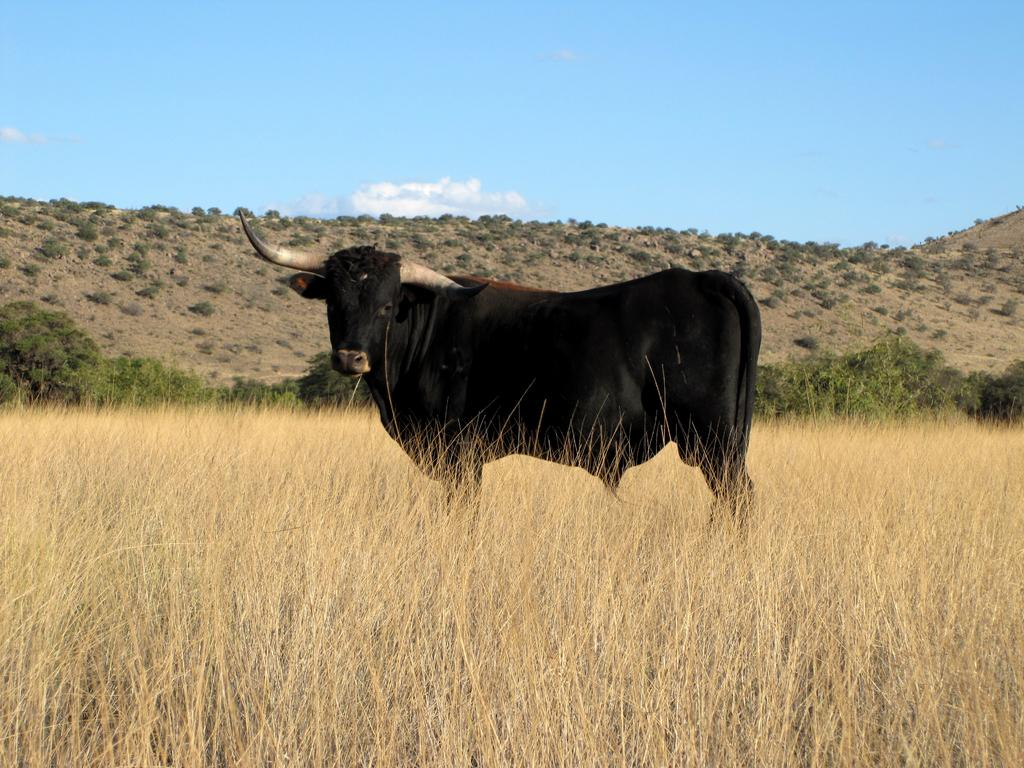What animal is the main subject of the picture? There is a bull in the picture. What is the terrain like where the bull is standing? The bull is standing in between dry grass. What can be seen behind the bull? There are trees behind the bull. What is visible in the distance beyond the trees? There are mountains behind the trees. What type of soda is the bull drinking in the picture? There is no soda present in the image; the bull is standing in dry grass with trees and mountains in the background. 